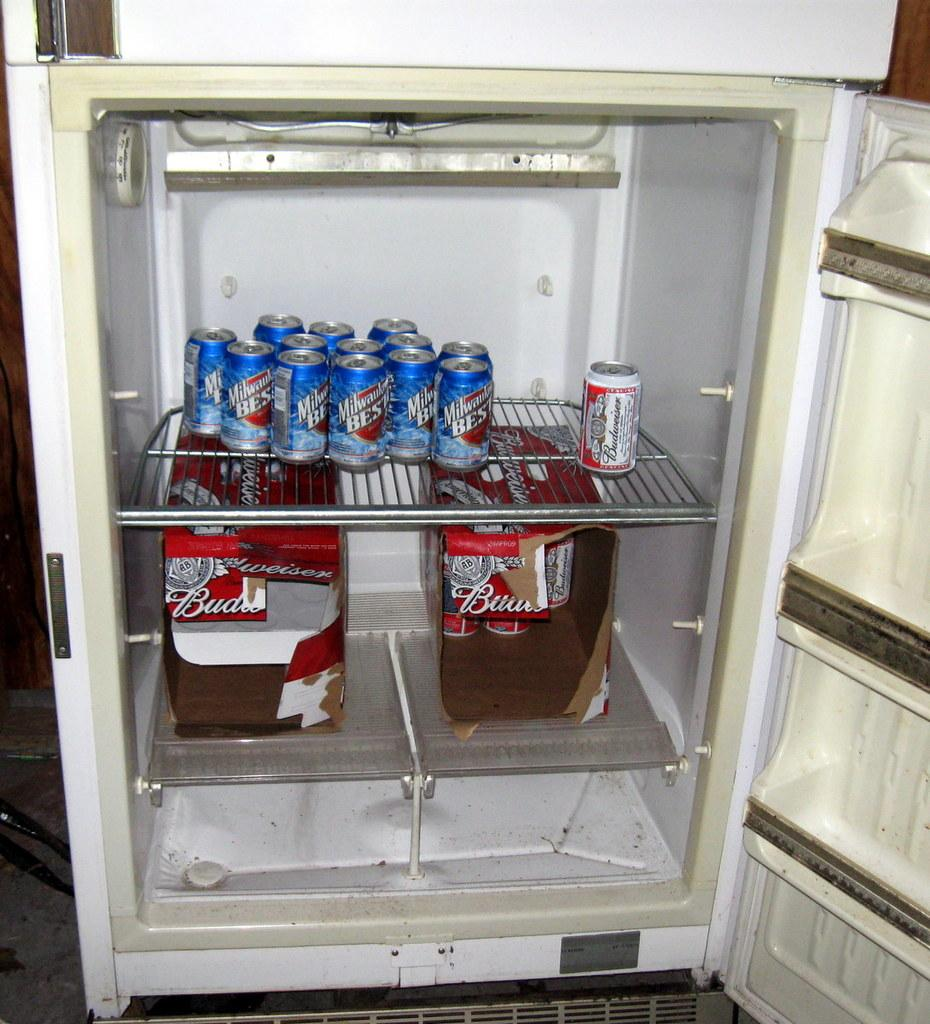<image>
Summarize the visual content of the image. open refrigerator with Milwaukee's Best and Budweiser beers 